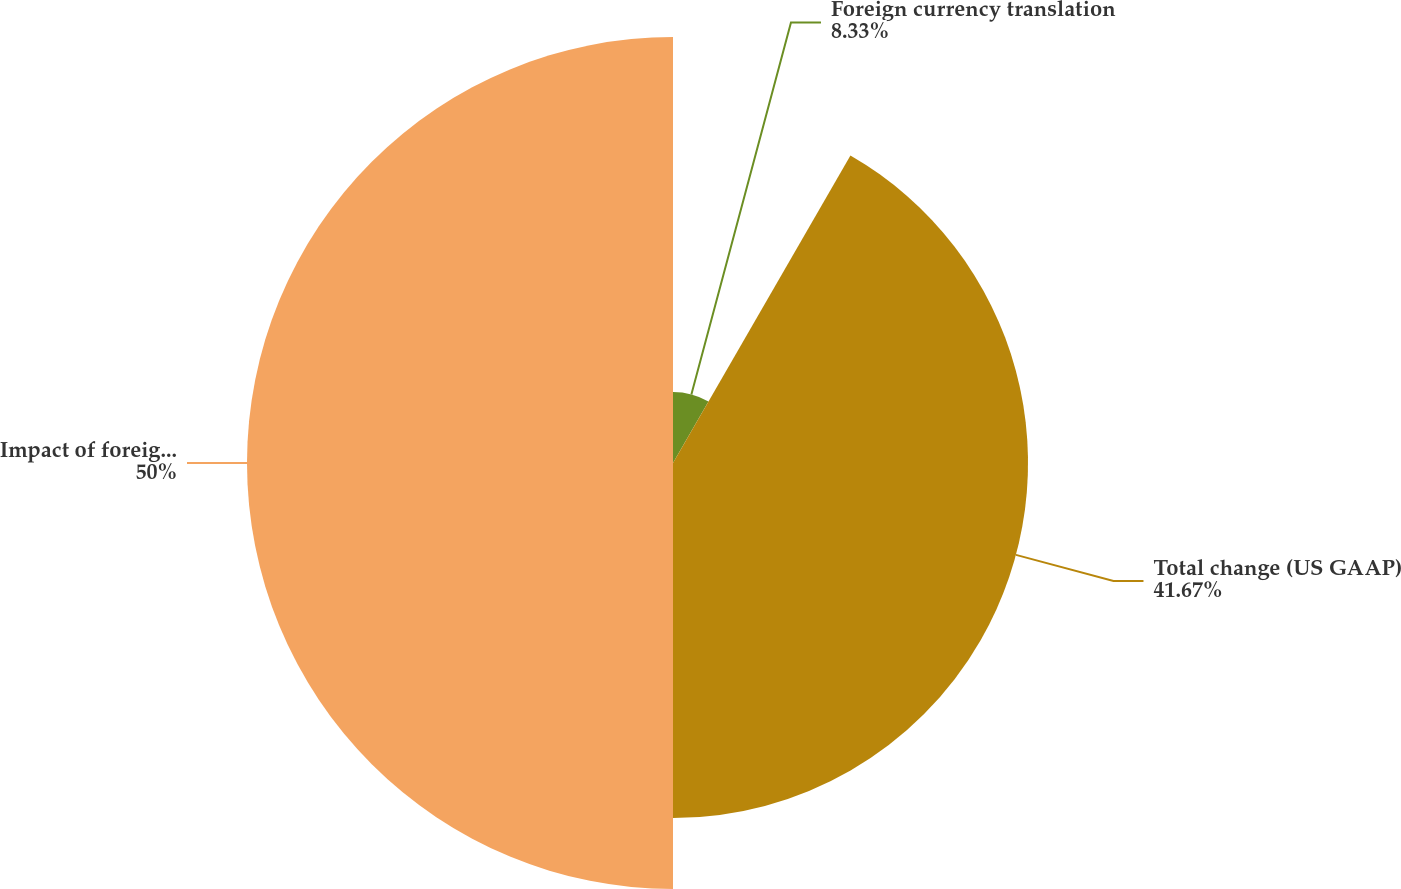Convert chart. <chart><loc_0><loc_0><loc_500><loc_500><pie_chart><fcel>Foreign currency translation<fcel>Total change (US GAAP)<fcel>Impact of foreign currency<nl><fcel>8.33%<fcel>41.67%<fcel>50.0%<nl></chart> 